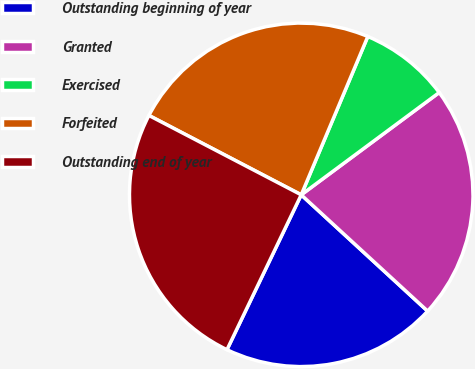<chart> <loc_0><loc_0><loc_500><loc_500><pie_chart><fcel>Outstanding beginning of year<fcel>Granted<fcel>Exercised<fcel>Forfeited<fcel>Outstanding end of year<nl><fcel>20.28%<fcel>21.99%<fcel>8.51%<fcel>23.69%<fcel>25.53%<nl></chart> 